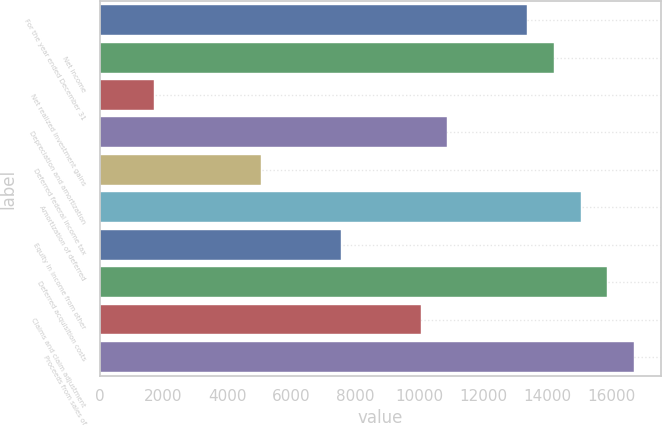Convert chart to OTSL. <chart><loc_0><loc_0><loc_500><loc_500><bar_chart><fcel>For the year ended December 31<fcel>Net income<fcel>Net realized investment gains<fcel>Depreciation and amortization<fcel>Deferred federal income tax<fcel>Amortization of deferred<fcel>Equity in income from other<fcel>Deferred acquisition costs<fcel>Claims and claim adjustment<fcel>Proceeds from sales of<nl><fcel>13367.6<fcel>14200.7<fcel>1704.2<fcel>10868.3<fcel>5036.6<fcel>15033.8<fcel>7535.9<fcel>15866.9<fcel>10035.2<fcel>16700<nl></chart> 